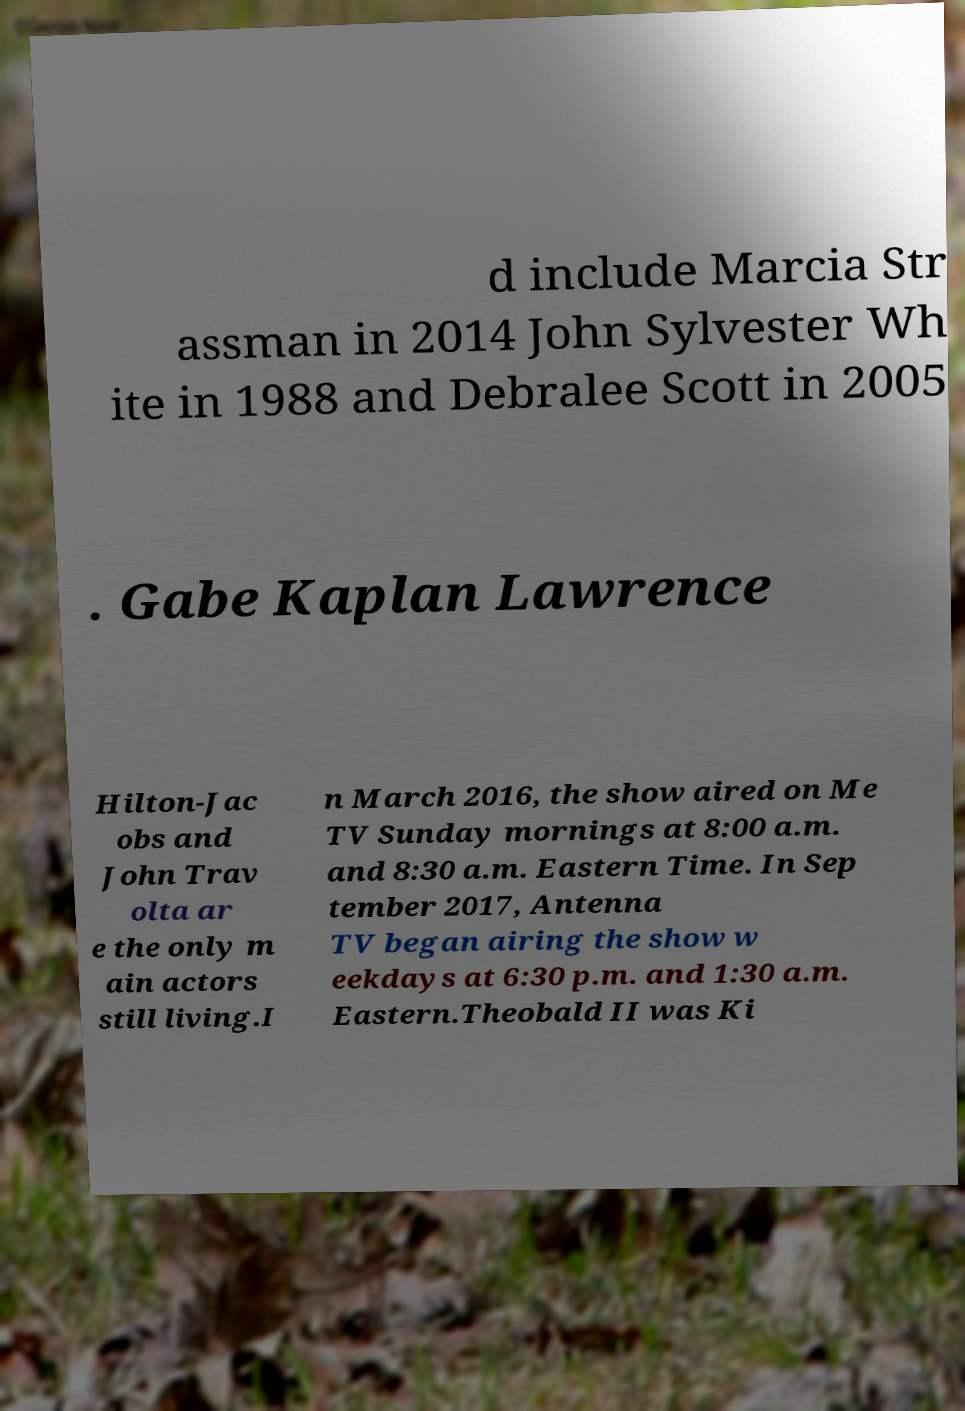Could you extract and type out the text from this image? d include Marcia Str assman in 2014 John Sylvester Wh ite in 1988 and Debralee Scott in 2005 . Gabe Kaplan Lawrence Hilton-Jac obs and John Trav olta ar e the only m ain actors still living.I n March 2016, the show aired on Me TV Sunday mornings at 8:00 a.m. and 8:30 a.m. Eastern Time. In Sep tember 2017, Antenna TV began airing the show w eekdays at 6:30 p.m. and 1:30 a.m. Eastern.Theobald II was Ki 